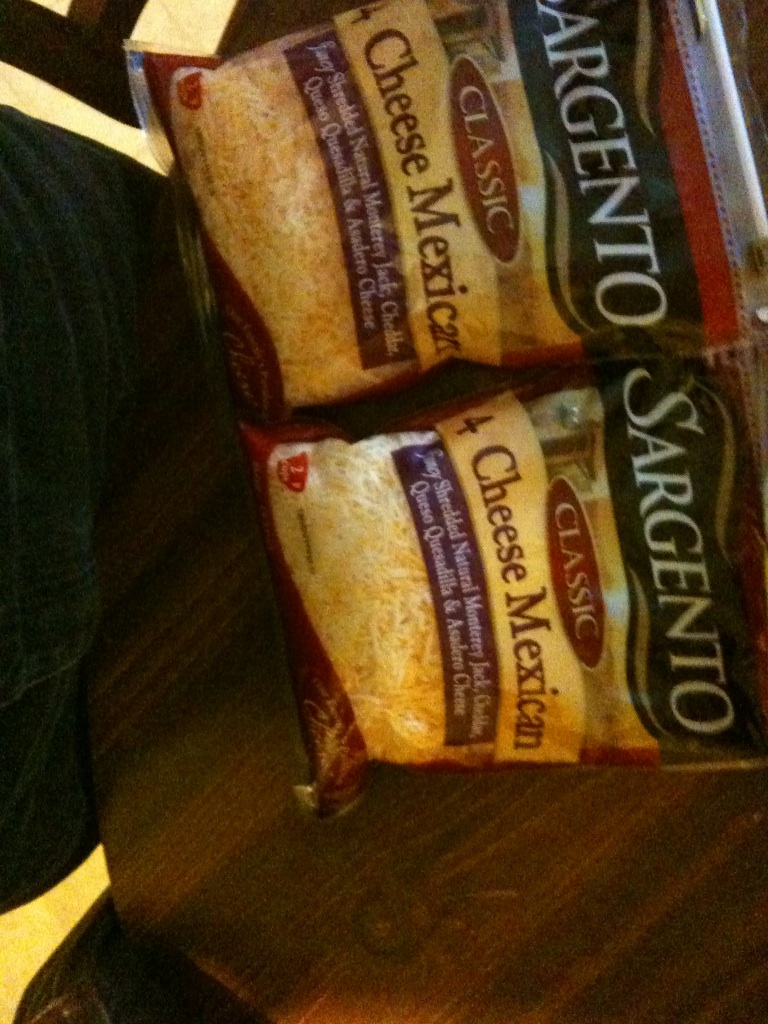What types of cheese are these? These are bags of Sargento Classic 4 Cheese Mexican blend. This blend typically includes Monterey Jack, Cheddar, Queso Quesadilla, and Asadero cheeses. 